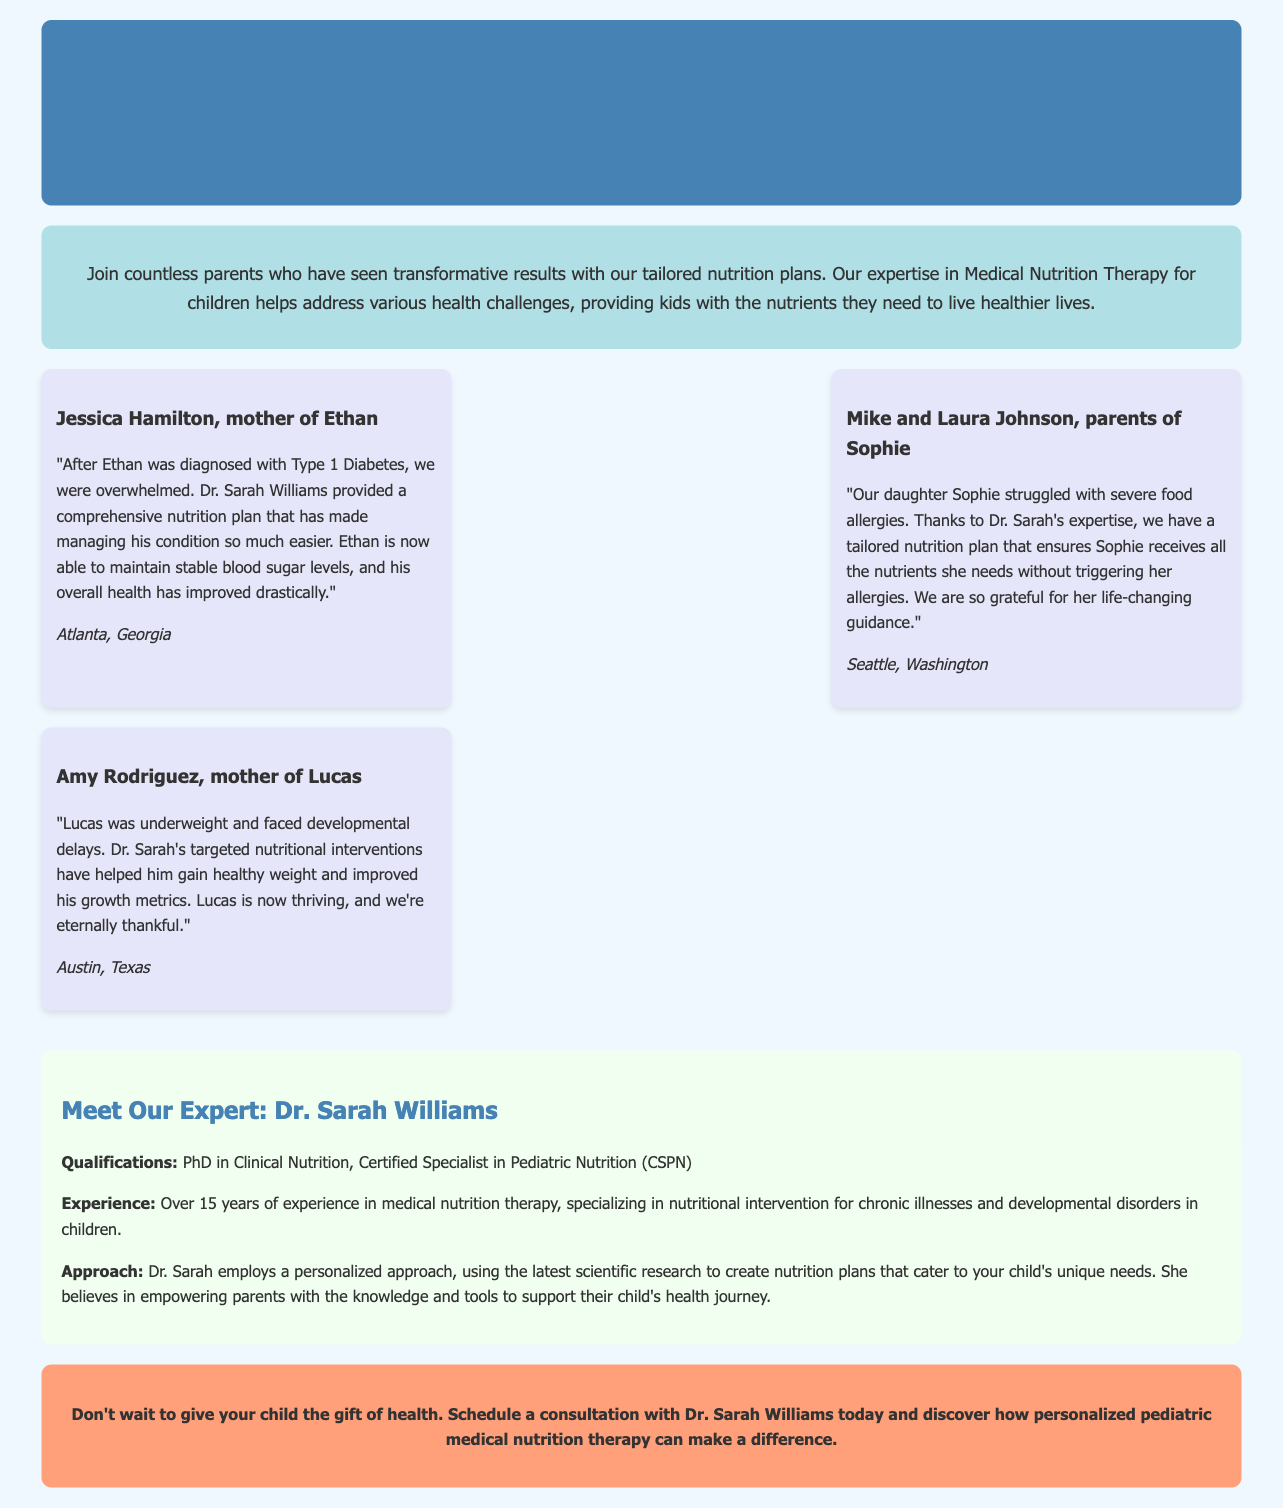What is the title of the advertisement? The title of the advertisement is prominently displayed at the top, focusing on transforming children's health through nutrition.
Answer: Transform Your Child's Health with Expert Pediatric Medical Nutrition Therapy Who is the expert in the advertisement? The advertisement identifies Dr. Sarah Williams as the expert providing pediatric medical nutrition therapy services.
Answer: Dr. Sarah Williams How many testimonials are provided in the document? The document features three testimonials from parents about their children's health improvements.
Answer: Three What health condition did Ethan have? The document states that Ethan was diagnosed with Type 1 Diabetes, which led to seeking nutrition therapy.
Answer: Type 1 Diabetes Which state does Jessica Hamilton reside in? The advertisement includes Jessica's location at the end of her testimonial, which specifies where she lives.
Answer: Georgia What specific issue did Sophie's parents face? The document indicates that Sophie's parents were dealing with severe food allergies that necessitated a tailored nutrition plan.
Answer: Severe food allergies How many years of experience does Dr. Sarah have? Dr. Sarah's experience level in medical nutrition therapy is mentioned specifically, indicating her extensive background.
Answer: Over 15 years What is the call to action in the advertisement? The closing section encourages parents to take immediate action by scheduling a consultation with Dr. Sarah for personalized nutrition therapy.
Answer: Schedule a consultation What kind of degree does Dr. Sarah hold? The advertisement lists Dr. Sarah's educational qualifications, stating she has a PhD in Clinical Nutrition.
Answer: PhD in Clinical Nutrition 